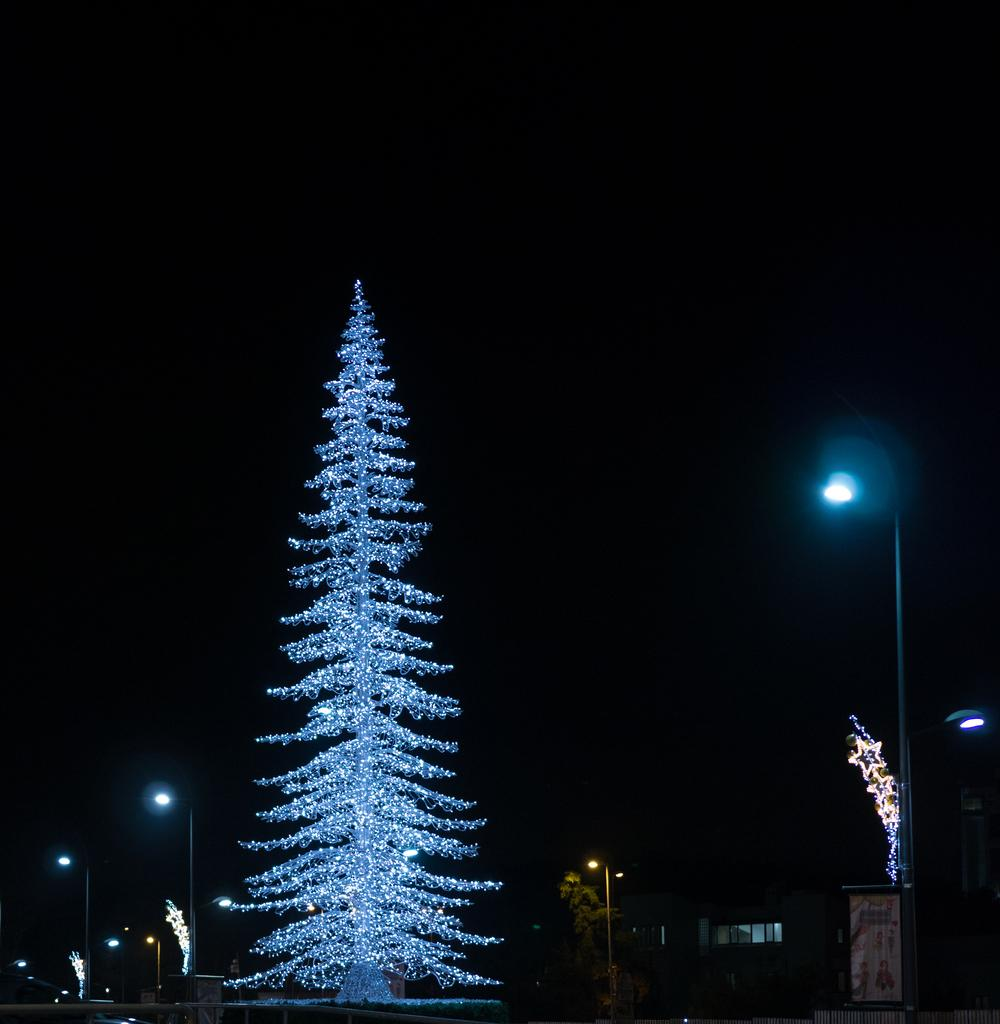What type of tree is in the image? There is a Christmas tree in the image. Where is the Christmas tree located in the image? The Christmas tree is on the left side of the image. What other object can be seen in the image? There is a pole in the image. Where is the pole located in the image? The pole is on the right side of the image. What type of grain is visible on the representative's calculator in the image? There is no representative or calculator present in the image, so there is no grain to be observed. 